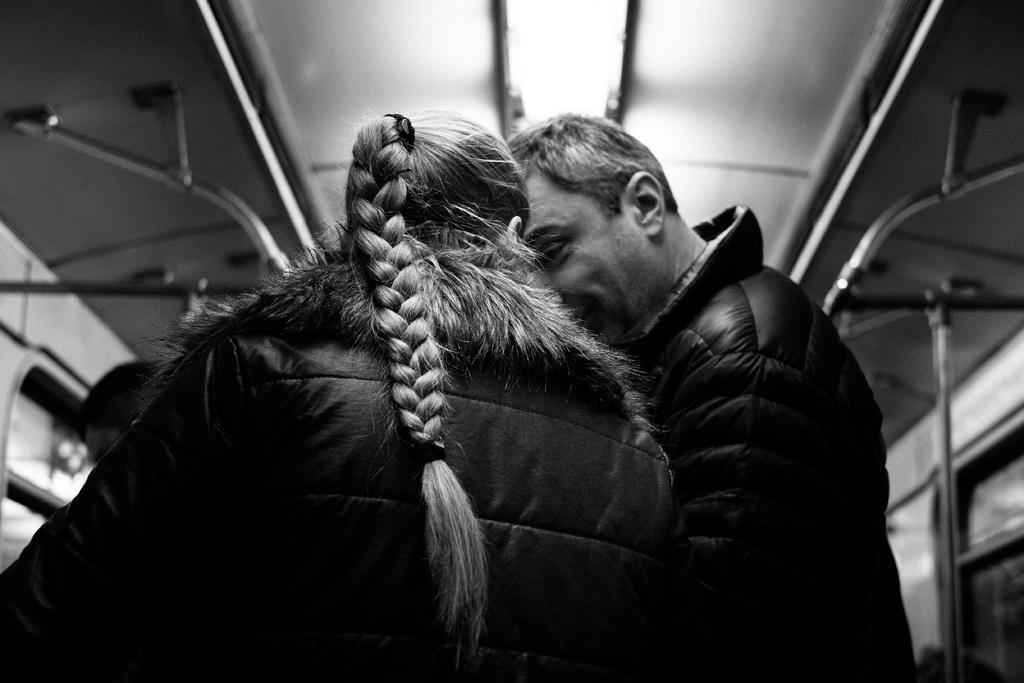In one or two sentences, can you explain what this image depicts? In this picture we can see persons and in the background we can see a roof,rods. 